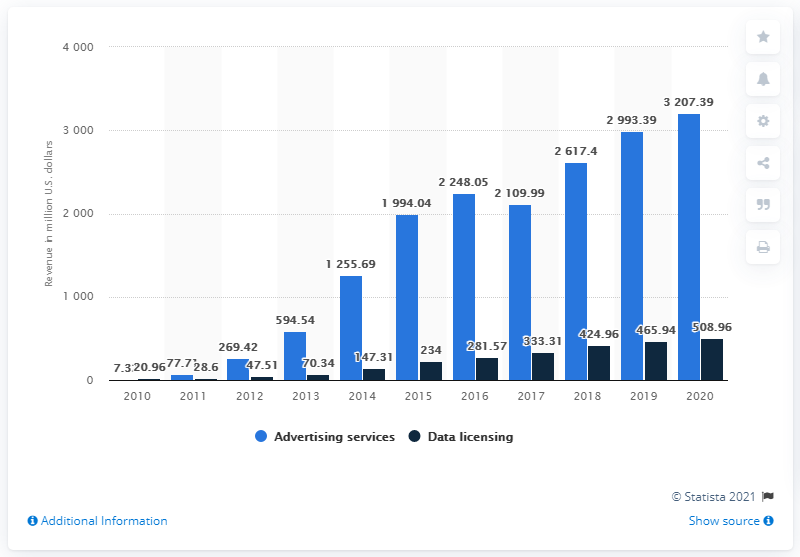Can you describe the trend of data licensing revenue for Twitter as seen in this chart? The chart displays a fluctuating yet overall increasing trend in data licensing revenue for Twitter. Starting from $47.51 million in 2011, there are year-by-year variations, culminating in $1.255.69 million in 2020. 